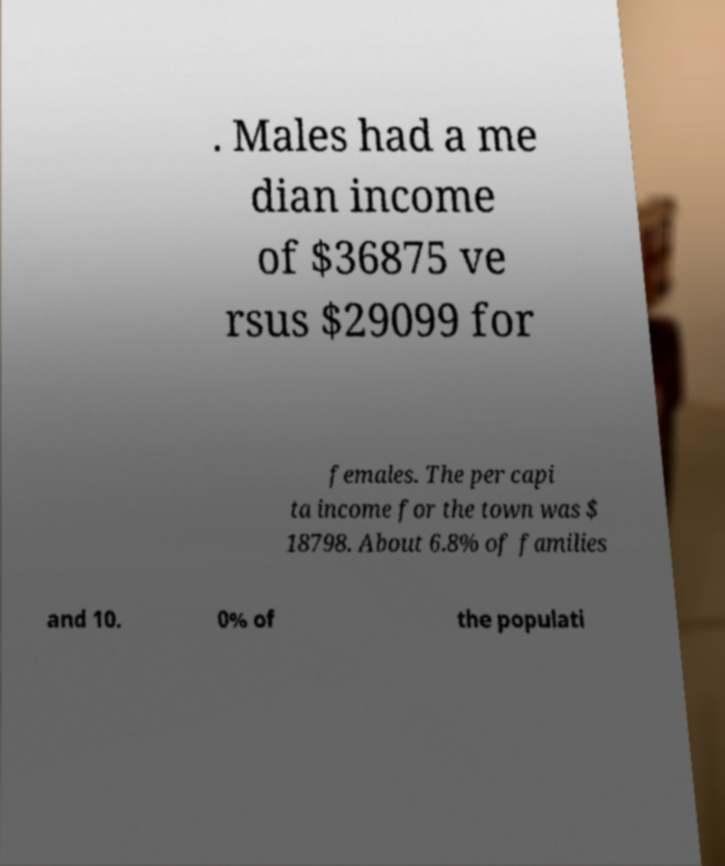For documentation purposes, I need the text within this image transcribed. Could you provide that? . Males had a me dian income of $36875 ve rsus $29099 for females. The per capi ta income for the town was $ 18798. About 6.8% of families and 10. 0% of the populati 